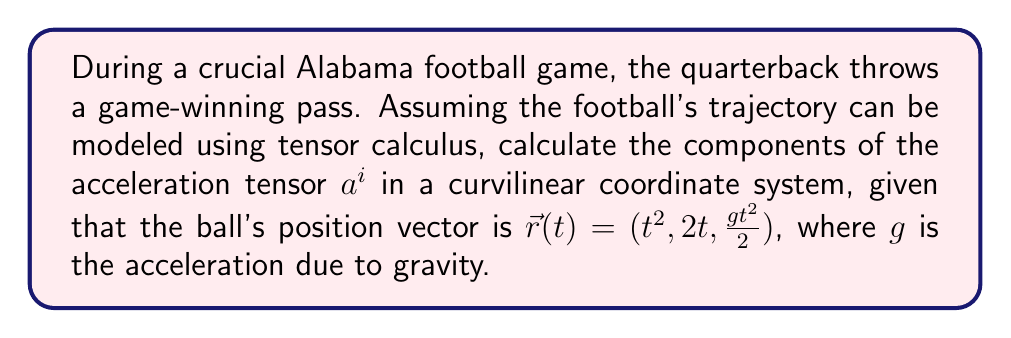Can you answer this question? To solve this problem, we'll follow these steps:

1) In curvilinear coordinates, the acceleration tensor $a^i$ is given by:

   $$a^i = \frac{d^2x^i}{dt^2} + \Gamma^i_{jk}\frac{dx^j}{dt}\frac{dx^k}{dt}$$

   where $\Gamma^i_{jk}$ are the Christoffel symbols.

2) First, let's calculate $\frac{dx^i}{dt}$ for each component:
   
   $$\frac{dx^1}{dt} = \frac{d}{dt}(t^2) = 2t$$
   $$\frac{dx^2}{dt} = \frac{d}{dt}(2t) = 2$$
   $$\frac{dx^3}{dt} = \frac{d}{dt}(\frac{gt^2}{2}) = gt$$

3) Now, let's calculate $\frac{d^2x^i}{dt^2}$ for each component:

   $$\frac{d^2x^1}{dt^2} = \frac{d}{dt}(2t) = 2$$
   $$\frac{d^2x^2}{dt^2} = \frac{d}{dt}(2) = 0$$
   $$\frac{d^2x^3}{dt^2} = \frac{d}{dt}(gt) = g$$

4) In this case, we're using a Cartesian coordinate system, so all Christoffel symbols $\Gamma^i_{jk} = 0$.

5) Therefore, the components of the acceleration tensor are simply:

   $$a^1 = \frac{d^2x^1}{dt^2} = 2$$
   $$a^2 = \frac{d^2x^2}{dt^2} = 0$$
   $$a^3 = \frac{d^2x^3}{dt^2} = g$$

Thus, the acceleration tensor $a^i$ has components $(2, 0, g)$.
Answer: $a^i = (2, 0, g)$ 